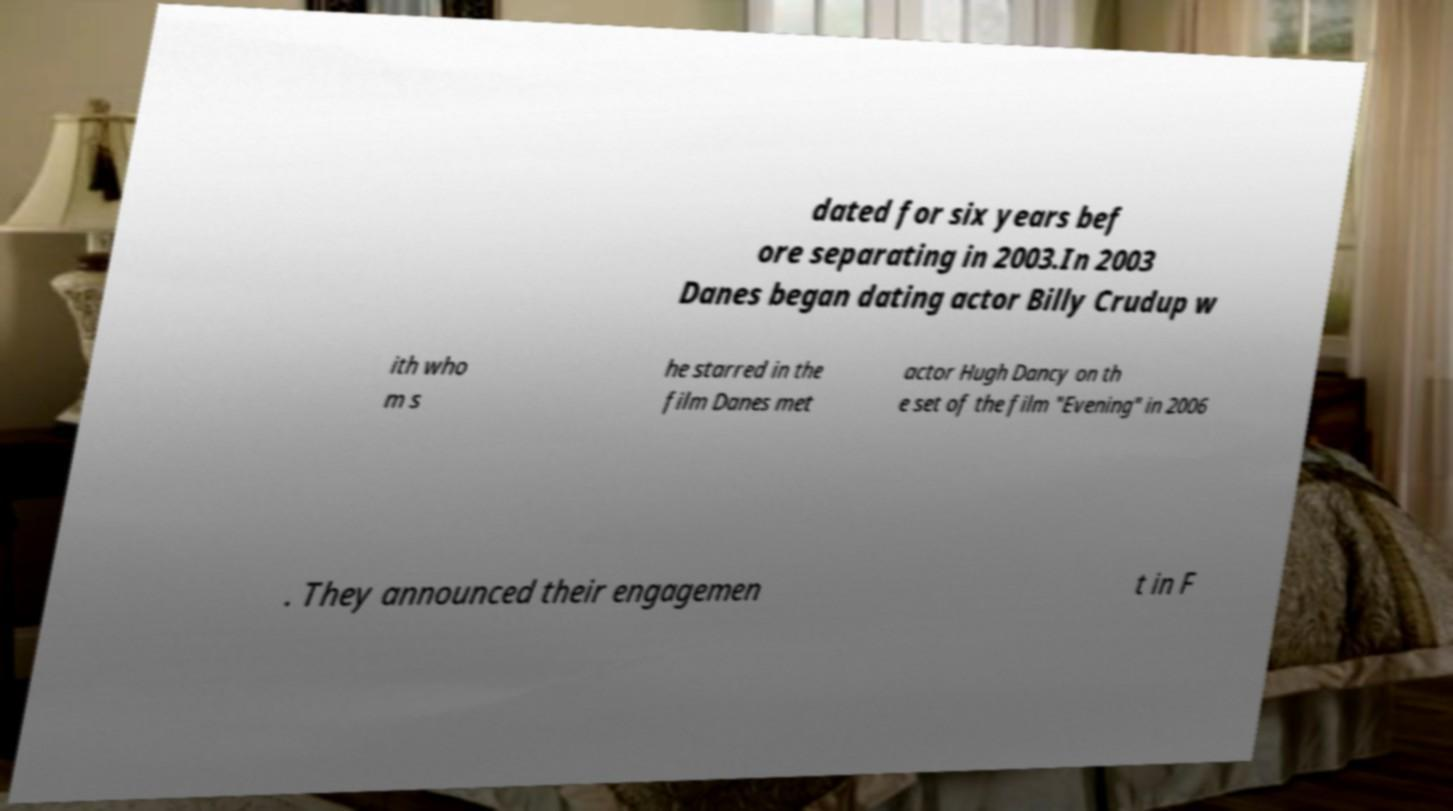For documentation purposes, I need the text within this image transcribed. Could you provide that? dated for six years bef ore separating in 2003.In 2003 Danes began dating actor Billy Crudup w ith who m s he starred in the film Danes met actor Hugh Dancy on th e set of the film "Evening" in 2006 . They announced their engagemen t in F 